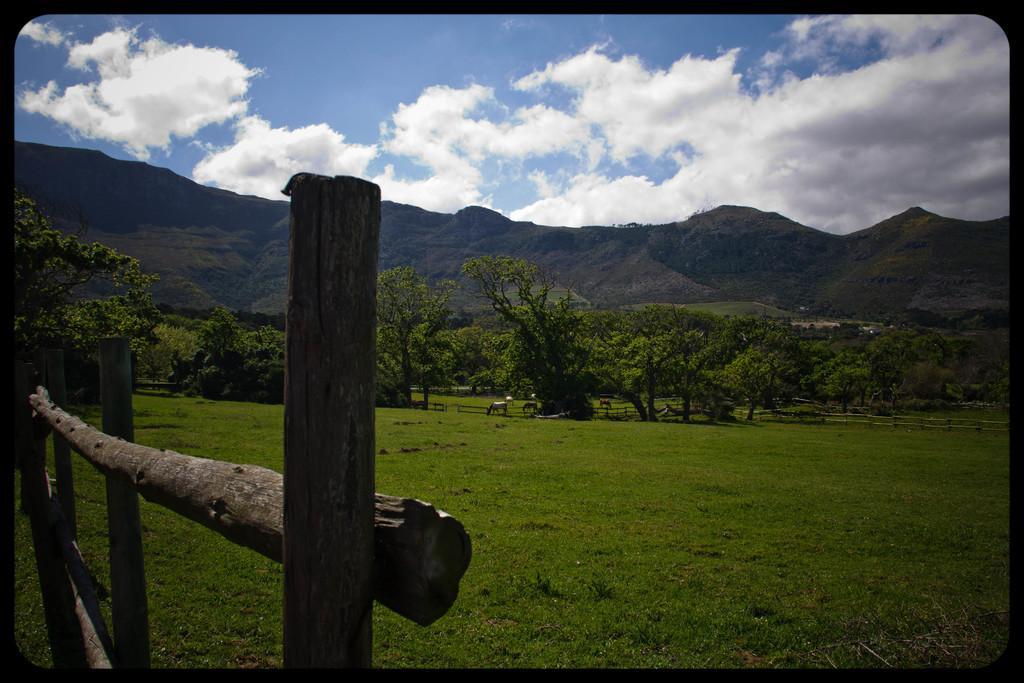Can you describe this image briefly? It looks like an edited image. We can see there are wooden fences, animals, trees, hills and the sky. 